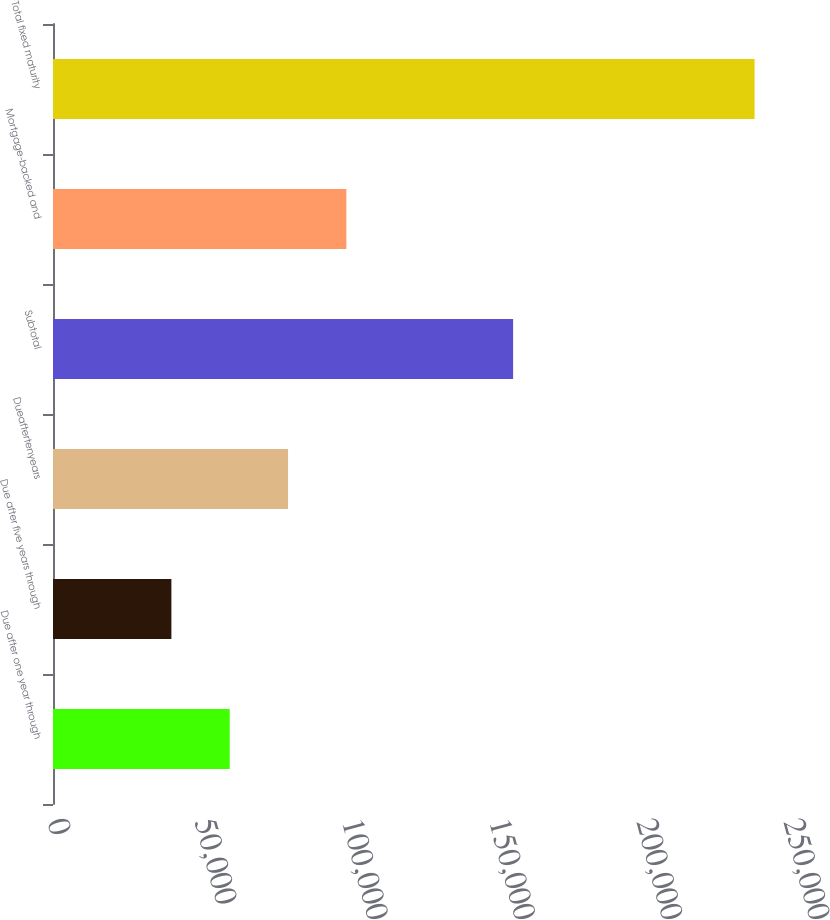<chart> <loc_0><loc_0><loc_500><loc_500><bar_chart><fcel>Due after one year through<fcel>Due after five years through<fcel>Dueaftertenyears<fcel>Subtotal<fcel>Mortgage-backed and<fcel>Total fixed maturity<nl><fcel>60023.2<fcel>40213<fcel>79833.4<fcel>156289<fcel>99643.6<fcel>238315<nl></chart> 